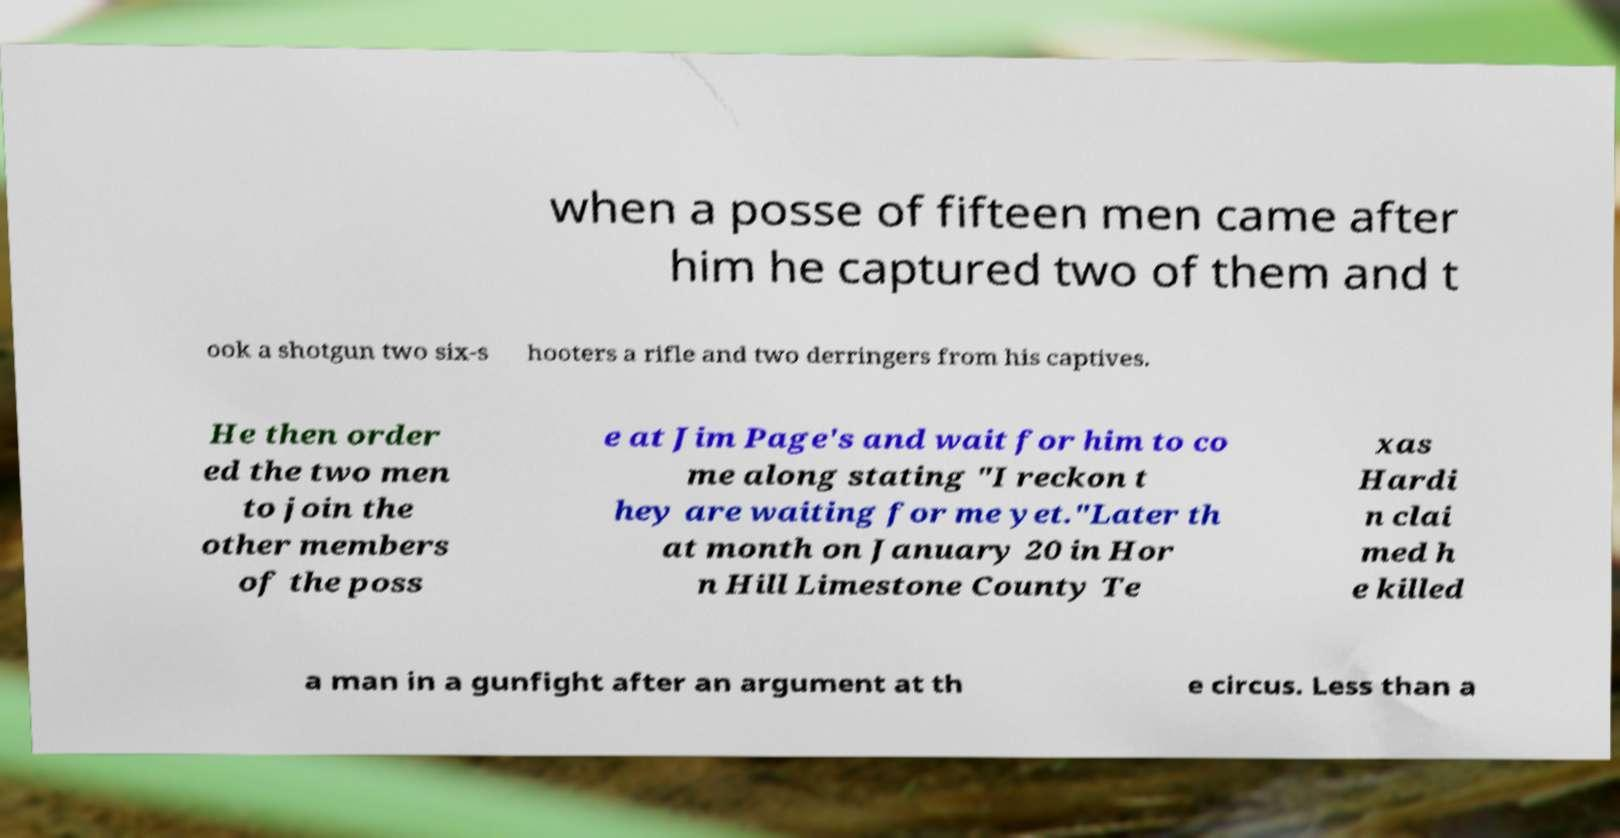Could you extract and type out the text from this image? when a posse of fifteen men came after him he captured two of them and t ook a shotgun two six-s hooters a rifle and two derringers from his captives. He then order ed the two men to join the other members of the poss e at Jim Page's and wait for him to co me along stating "I reckon t hey are waiting for me yet."Later th at month on January 20 in Hor n Hill Limestone County Te xas Hardi n clai med h e killed a man in a gunfight after an argument at th e circus. Less than a 